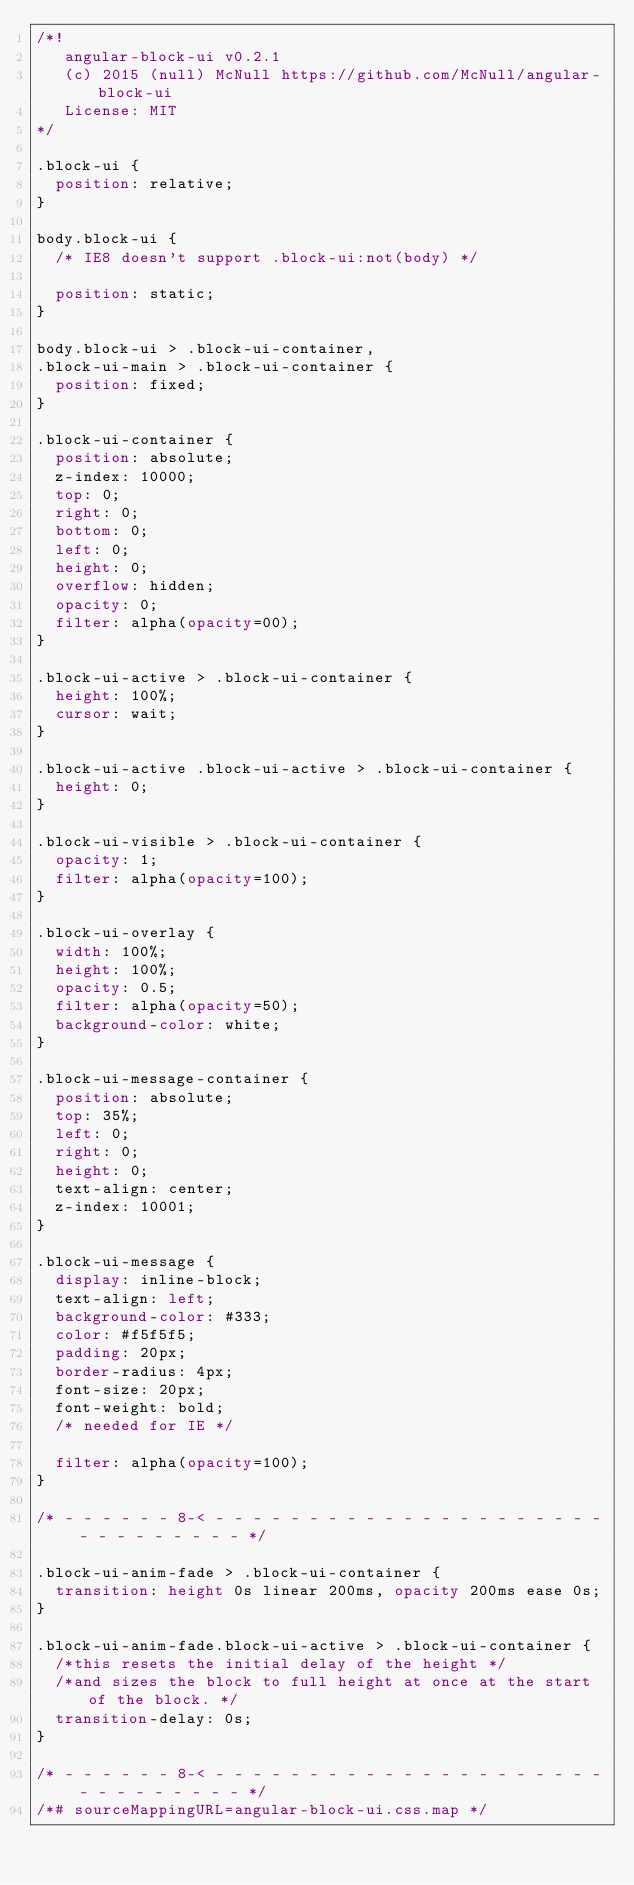Convert code to text. <code><loc_0><loc_0><loc_500><loc_500><_CSS_>/*!
   angular-block-ui v0.2.1
   (c) 2015 (null) McNull https://github.com/McNull/angular-block-ui
   License: MIT
*/

.block-ui {
  position: relative;
}

body.block-ui {
  /* IE8 doesn't support .block-ui:not(body) */
  
  position: static;
}

body.block-ui > .block-ui-container,
.block-ui-main > .block-ui-container {
  position: fixed;
}

.block-ui-container {
  position: absolute;
  z-index: 10000;
  top: 0;
  right: 0;
  bottom: 0;
  left: 0;
  height: 0;
  overflow: hidden;
  opacity: 0;
  filter: alpha(opacity=00);
}

.block-ui-active > .block-ui-container {
  height: 100%;
  cursor: wait;
}

.block-ui-active .block-ui-active > .block-ui-container {
  height: 0;
}

.block-ui-visible > .block-ui-container {
  opacity: 1;
  filter: alpha(opacity=100);
}

.block-ui-overlay {
  width: 100%;
  height: 100%;
  opacity: 0.5;
  filter: alpha(opacity=50);
  background-color: white;
}

.block-ui-message-container {
  position: absolute;
  top: 35%;
  left: 0;
  right: 0;
  height: 0;
  text-align: center;
  z-index: 10001;
}

.block-ui-message {
  display: inline-block;
  text-align: left;
  background-color: #333;
  color: #f5f5f5;
  padding: 20px;
  border-radius: 4px;
  font-size: 20px;
  font-weight: bold;
  /* needed for IE */
  
  filter: alpha(opacity=100);
}

/* - - - - - - 8-< - - - - - - - - - - - - - - - - - - - - - - - - - - - - - - */

.block-ui-anim-fade > .block-ui-container {
  transition: height 0s linear 200ms, opacity 200ms ease 0s;
}

.block-ui-anim-fade.block-ui-active > .block-ui-container {
  /*this resets the initial delay of the height */
  /*and sizes the block to full height at once at the start of the block. */
  transition-delay: 0s;
}

/* - - - - - - 8-< - - - - - - - - - - - - - - - - - - - - - - - - - - - - - - */
/*# sourceMappingURL=angular-block-ui.css.map */</code> 